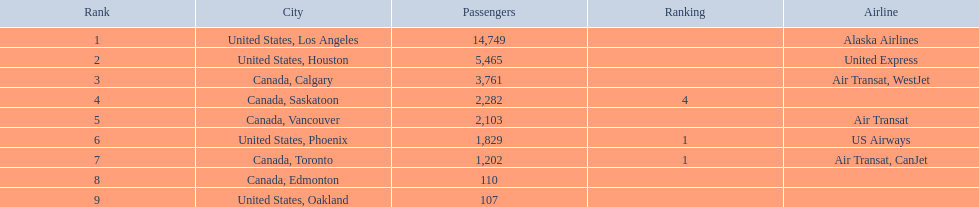What are the cities that are associated with the playa de oro international airport? United States, Los Angeles, United States, Houston, Canada, Calgary, Canada, Saskatoon, Canada, Vancouver, United States, Phoenix, Canada, Toronto, Canada, Edmonton, United States, Oakland. What is uniteed states, los angeles passenger count? 14,749. What other cities passenger count would lead to 19,000 roughly when combined with previous los angeles? Canada, Calgary. 